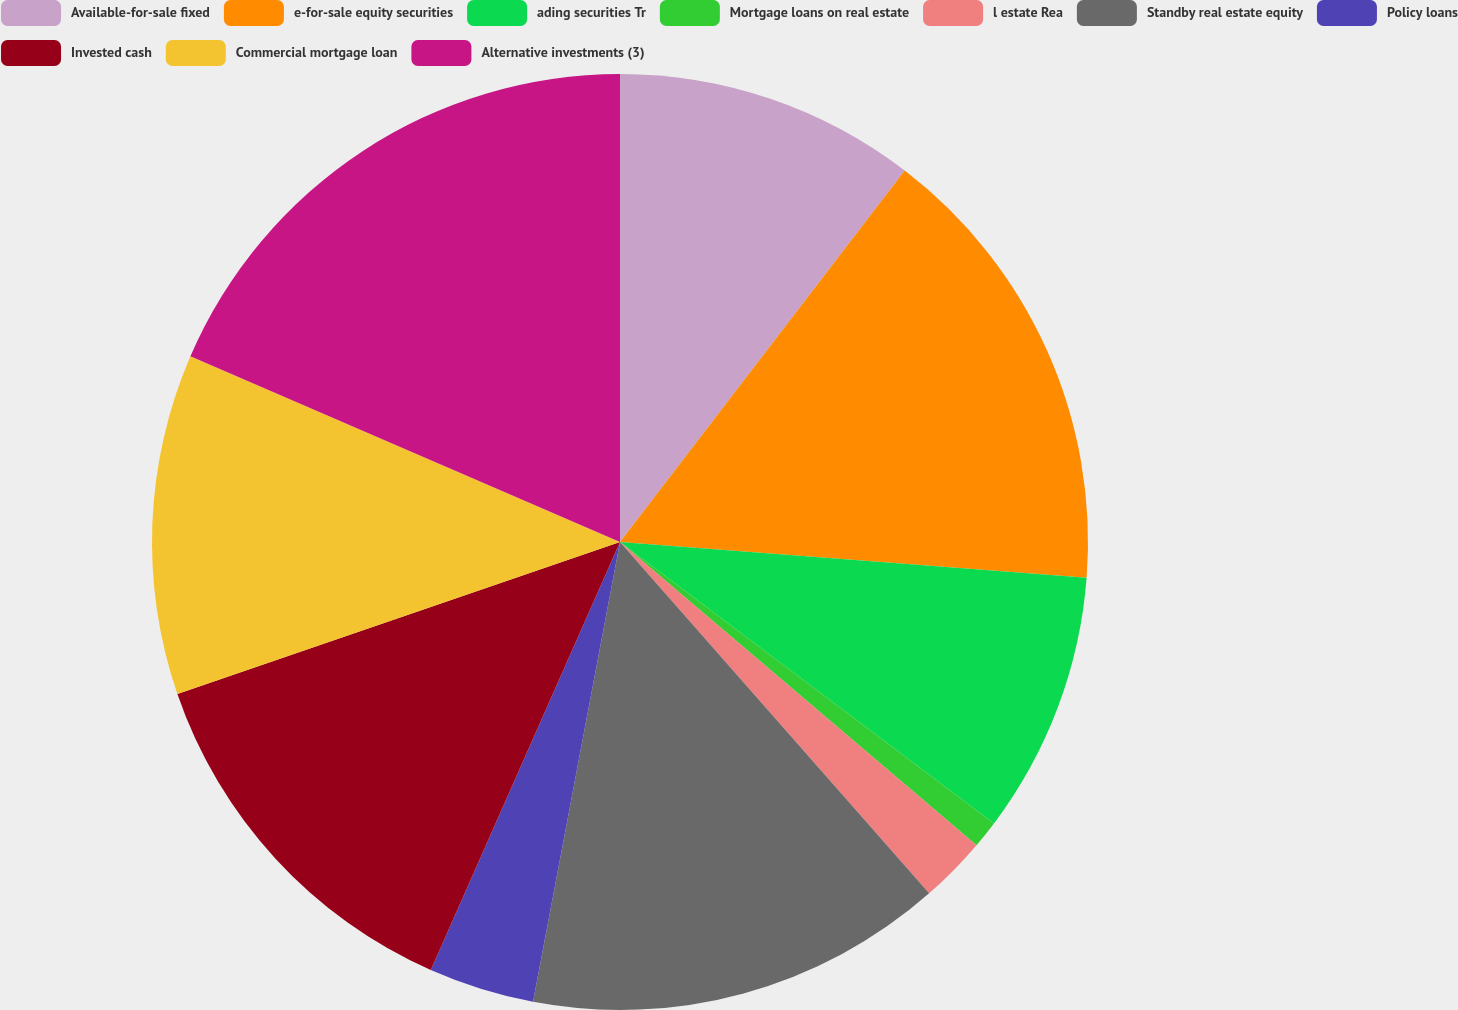Convert chart. <chart><loc_0><loc_0><loc_500><loc_500><pie_chart><fcel>Available-for-sale fixed<fcel>e-for-sale equity securities<fcel>ading securities Tr<fcel>Mortgage loans on real estate<fcel>l estate Rea<fcel>Standby real estate equity<fcel>Policy loans<fcel>Invested cash<fcel>Commercial mortgage loan<fcel>Alternative investments (3)<nl><fcel>10.41%<fcel>15.81%<fcel>9.05%<fcel>0.95%<fcel>2.3%<fcel>14.46%<fcel>3.65%<fcel>13.11%<fcel>11.76%<fcel>18.51%<nl></chart> 